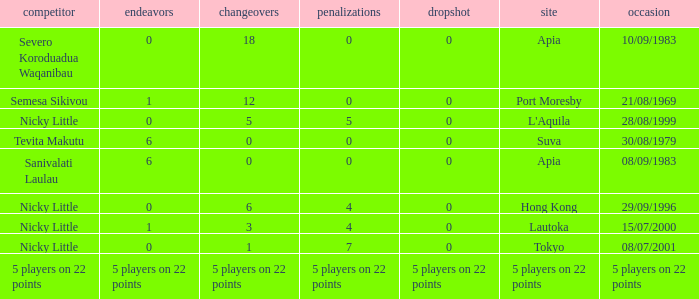How many conversions had 0 pens and 0 tries? 18.0. 